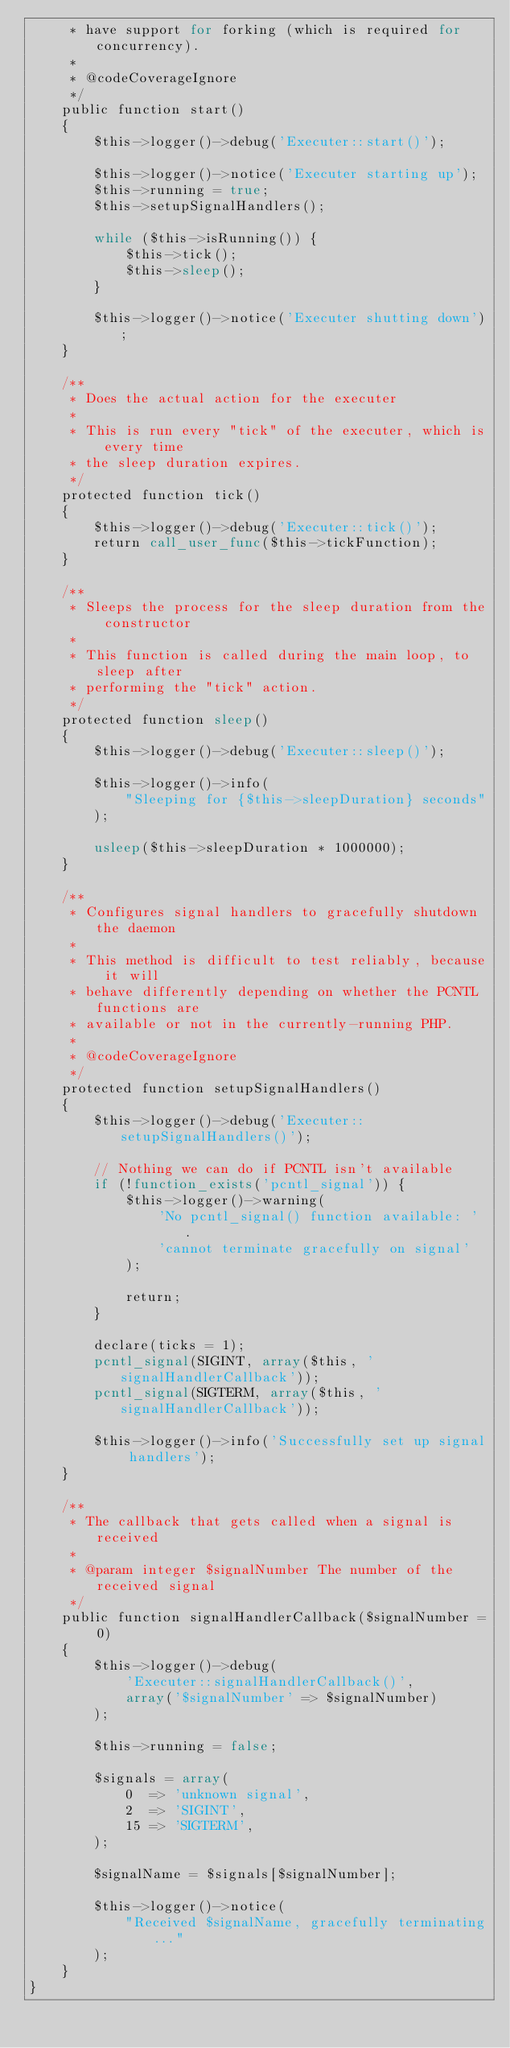Convert code to text. <code><loc_0><loc_0><loc_500><loc_500><_PHP_>     * have support for forking (which is required for concurrency).
     *
     * @codeCoverageIgnore
     */
    public function start()
    {
        $this->logger()->debug('Executer::start()');

        $this->logger()->notice('Executer starting up');
        $this->running = true;
        $this->setupSignalHandlers();

        while ($this->isRunning()) {
            $this->tick();
            $this->sleep();
        }

        $this->logger()->notice('Executer shutting down');
    }

    /**
     * Does the actual action for the executer
     *
     * This is run every "tick" of the executer, which is every time
     * the sleep duration expires.
     */
    protected function tick()
    {
        $this->logger()->debug('Executer::tick()');
        return call_user_func($this->tickFunction);
    }

    /**
     * Sleeps the process for the sleep duration from the constructor
     *
     * This function is called during the main loop, to sleep after
     * performing the "tick" action.
     */
    protected function sleep()
    {
        $this->logger()->debug('Executer::sleep()');

        $this->logger()->info(
            "Sleeping for {$this->sleepDuration} seconds"
        );

        usleep($this->sleepDuration * 1000000);
    }

    /**
     * Configures signal handlers to gracefully shutdown the daemon
     *
     * This method is difficult to test reliably, because it will
     * behave differently depending on whether the PCNTL functions are
     * available or not in the currently-running PHP.
     *
     * @codeCoverageIgnore
     */
    protected function setupSignalHandlers()
    {
        $this->logger()->debug('Executer::setupSignalHandlers()');

        // Nothing we can do if PCNTL isn't available
        if (!function_exists('pcntl_signal')) {
            $this->logger()->warning(
                'No pcntl_signal() function available: ' .
                'cannot terminate gracefully on signal'
            );

            return;
        }

        declare(ticks = 1);
        pcntl_signal(SIGINT, array($this, 'signalHandlerCallback'));
        pcntl_signal(SIGTERM, array($this, 'signalHandlerCallback'));

        $this->logger()->info('Successfully set up signal handlers');
    }

    /**
     * The callback that gets called when a signal is received
     *
     * @param integer $signalNumber The number of the received signal
     */
    public function signalHandlerCallback($signalNumber = 0)
    {
        $this->logger()->debug(
            'Executer::signalHandlerCallback()',
            array('$signalNumber' => $signalNumber)
        );

        $this->running = false;

        $signals = array(
            0  => 'unknown signal',
            2  => 'SIGINT',
            15 => 'SIGTERM',
        );

        $signalName = $signals[$signalNumber];

        $this->logger()->notice(
            "Received $signalName, gracefully terminating..."
        );
    }
}
</code> 